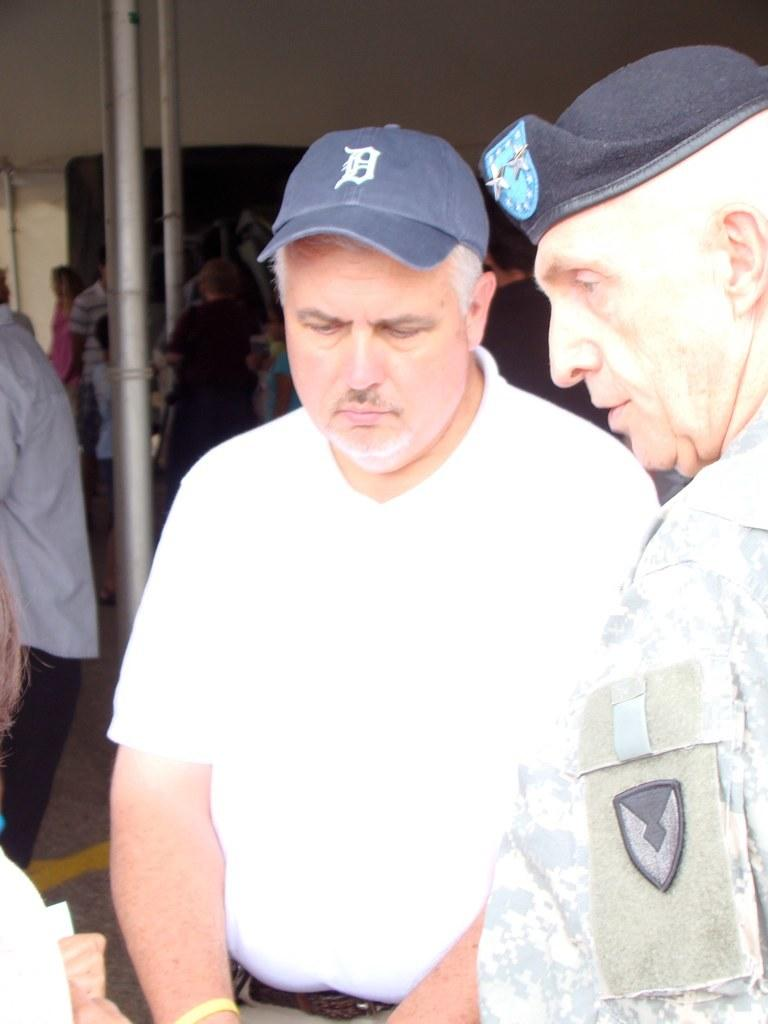What is happening in the image? There are people standing in the image. What can be seen behind the people? There are poles behind the people. What is visible in the background of the image? There is a wall in the background of the image. What type of twig is being used by the people in the image? There is no twig present in the image; the people are simply standing. 